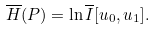Convert formula to latex. <formula><loc_0><loc_0><loc_500><loc_500>\overline { H } ( P ) = \ln \overline { I } [ u _ { 0 } , u _ { 1 } ] .</formula> 